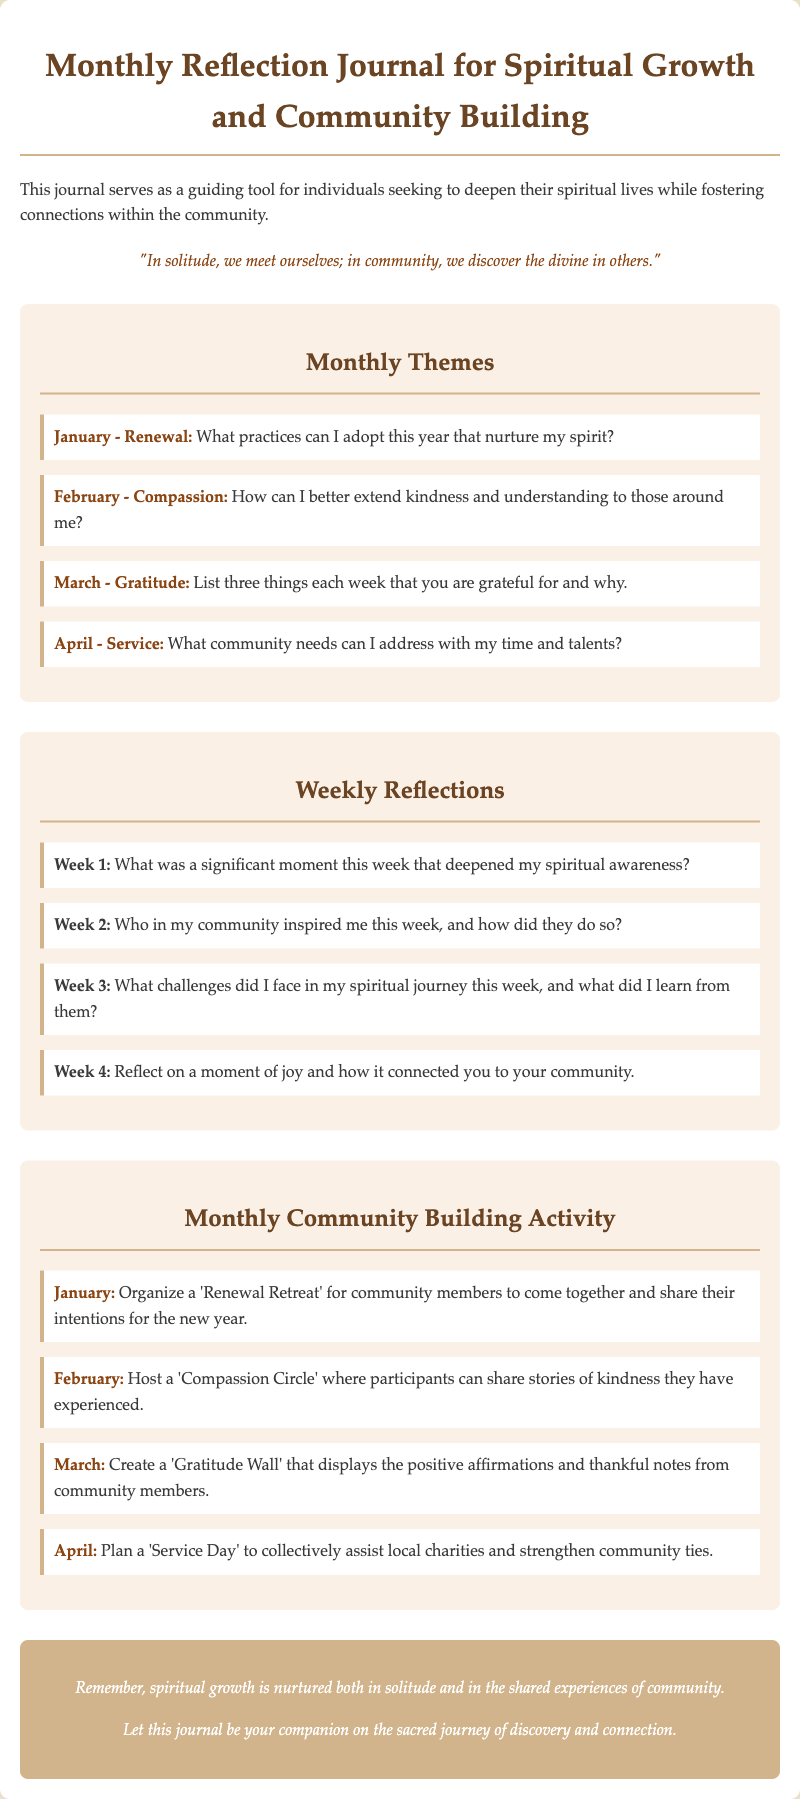What is the title of the document? The title is prominently displayed at the top of the document, serving as an introduction to its purpose.
Answer: Monthly Reflection Journal for Spiritual Growth and Community Building What month focuses on Compassion? This question requires identifying specific thematic months mentioned within the document.
Answer: February What activity is suggested for January? The document provides specific activities for each month, ensuring clarity in community engagement.
Answer: Organize a 'Renewal Retreat' What is the significant moment reflection question for Week 1? This question necessitates retrieving a specific reflection prompt from the weekly section of the journal.
Answer: What was a significant moment this week that deepened my spiritual awareness? How many monthly themes are presented? This question includes some reasoning, as one must count the themes provided within the document.
Answer: Four What is the purpose of the journal? The opening description provides insight into the intended use and goal of the journal.
Answer: To deepen spiritual lives while fostering connections What color theme is used for the conclusion? Analyzing the visual design elements within the document will answer this inquiry.
Answer: #d2b48c What is the focus of the month of March's theme? The themes are explicitly stated, allowing for straightforward retrieval of specific monthly focuses.
Answer: Gratitude What is the quote featured in the document? The document contains a quote that encapsulates its ethos and goals for reflection and community.
Answer: "In solitude, we meet ourselves; in community, we discover the divine in others." 